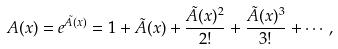<formula> <loc_0><loc_0><loc_500><loc_500>A ( x ) = e ^ { \tilde { A } ( x ) } = 1 + \tilde { A } ( x ) + \frac { \tilde { A } ( x ) ^ { 2 } } { 2 ! } + \frac { \tilde { A } ( x ) ^ { 3 } } { 3 ! } + \cdots ,</formula> 